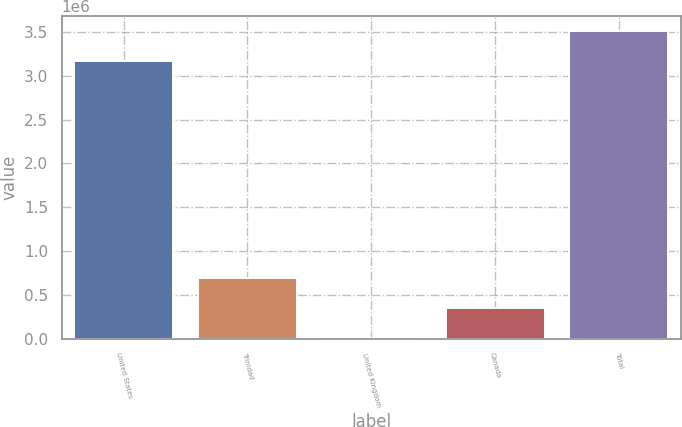Convert chart to OTSL. <chart><loc_0><loc_0><loc_500><loc_500><bar_chart><fcel>United States<fcel>Trinidad<fcel>United Kingdom<fcel>Canada<fcel>Total<nl><fcel>3.16236e+06<fcel>693908<fcel>11830<fcel>352869<fcel>3.5034e+06<nl></chart> 